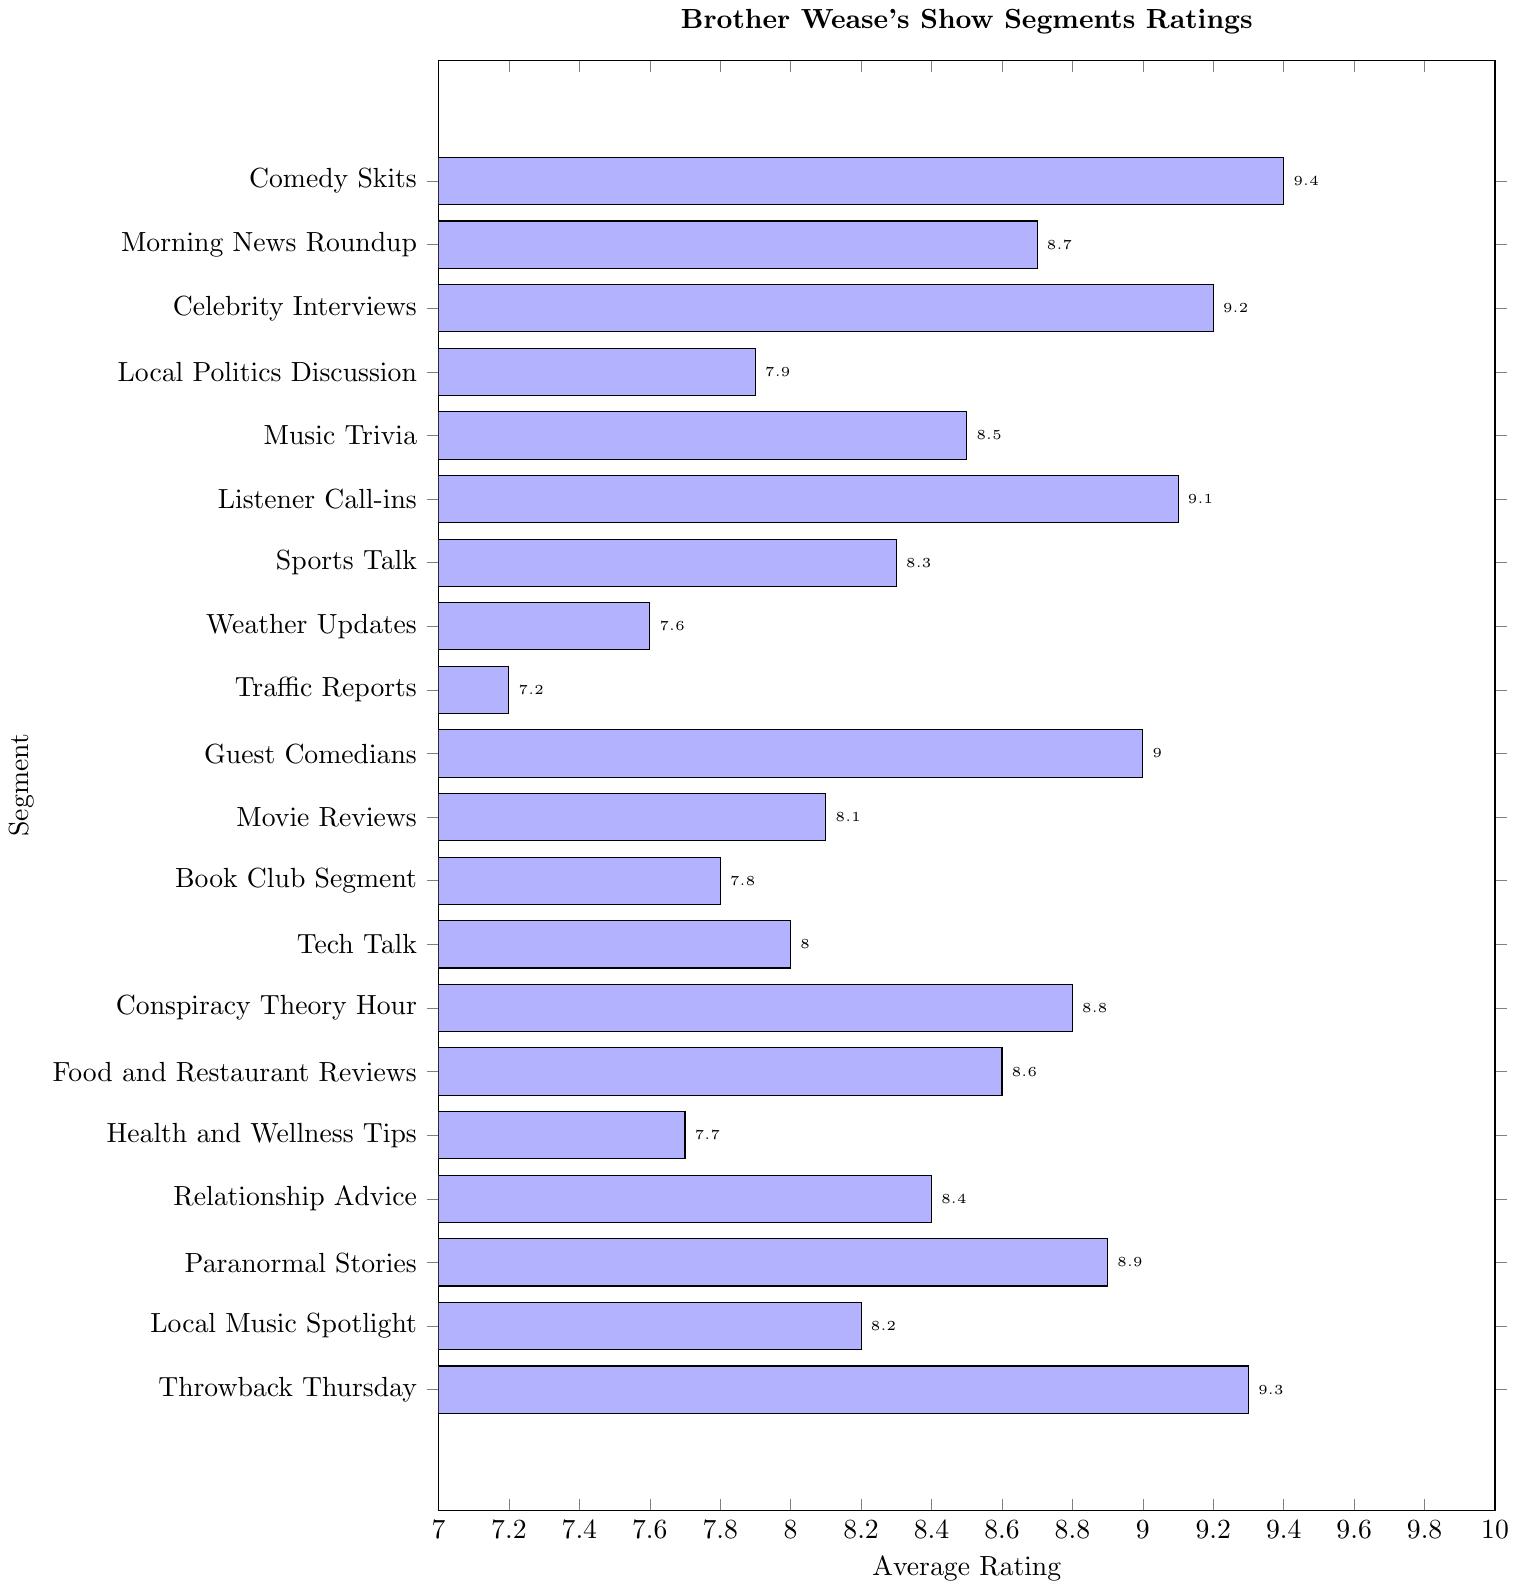What's the highest-rated segment? The highest-rated segment can be found by identifying the tallest bar on the plot representing Brother Wease's show segments ratings, which corresponds to "Comedy Skits" with a rating of 9.4.
Answer: Comedy Skits What's the lowest-rated segment? The lowest-rated segment can be determined by finding the shortest bar on the plot, which corresponds to "Traffic Reports" with a rating of 7.2.
Answer: Traffic Reports Which segment is rated higher: "Movie Reviews" or "Local Music Spotlight"? To compare, locate the bars for both segments: "Movie Reviews" (8.1) and "Local Music Spotlight" (8.2). "Local Music Spotlight" has a longer bar and a higher rating.
Answer: Local Music Spotlight What is the average rating of "Guest Comedians" and "Celebrity Interviews"? First, find the ratings for "Guest Comedians" (9.0) and "Celebrity Interviews" (9.2). Sum these two ratings (9.0 + 9.2 = 18.2) and divide by 2 to get the average rating: 18.2 / 2 = 9.1.
Answer: 9.1 How many segments have ratings above 9.0? Count the number of bars with ratings above 9.0 by checking each segment: "Celebrity Interviews" (9.2), "Listener Call-ins" (9.1), "Comedy Skits" (9.4), "Guest Comedians" (9.0), "Paranormal Stories" (8.9), and "Throwback Thursday" (9.3). We have 3 segments with ratings above 9.0.
Answer: 3 What’s the difference in ratings between the highest and lowest-rated segments? Identify the ratings for the highest ("Comedy Skits" at 9.4) and lowest ("Traffic Reports" at 7.2) and then find the difference: 9.4 - 7.2 = 2.2.
Answer: 2.2 Which segment has the median rating? To find the median in a sorted list of ratings (7.2, 7.6, 7.7, 7.8, 7.9, 8.0, 8.1, 8.2, 8.3, 8.4, 8.5, 8.6, 8.7, 8.8, 8.9, 9.0, 9.1, 9.2, 9.3, 9.4), locate the middle value. Since there are 20 segments, the median rating is the average of the 10th and 11th values: (8.4 + 8.5) / 2 = 8.45, corresponding to segments "Relationship Advice" and "Music Trivia".
Answer: Relationship Advice and Music Trivia Which segment's bar color has the lightest shade of blue? Observe the colormap gradient and find the segment with the lightest shade, which represents the lowest rating. "Traffic Reports" has the lightest shade of blue with a rating of 7.2.
Answer: Traffic Reports 